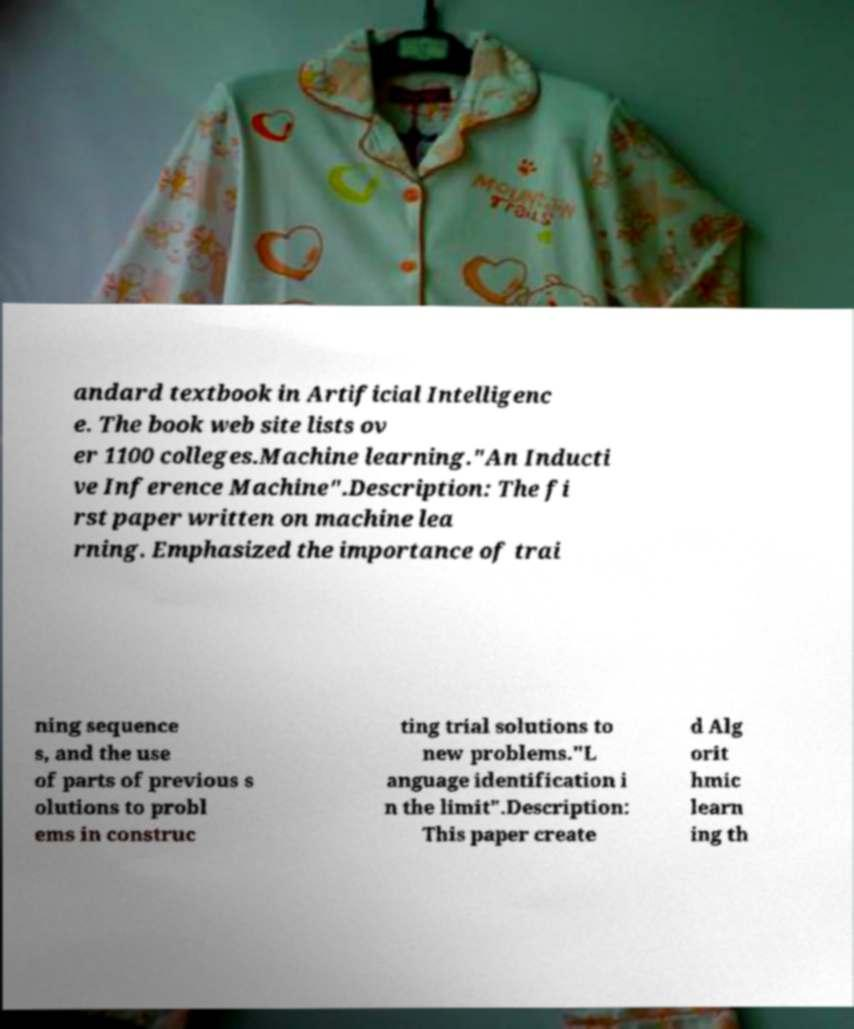Can you accurately transcribe the text from the provided image for me? andard textbook in Artificial Intelligenc e. The book web site lists ov er 1100 colleges.Machine learning."An Inducti ve Inference Machine".Description: The fi rst paper written on machine lea rning. Emphasized the importance of trai ning sequence s, and the use of parts of previous s olutions to probl ems in construc ting trial solutions to new problems."L anguage identification i n the limit".Description: This paper create d Alg orit hmic learn ing th 